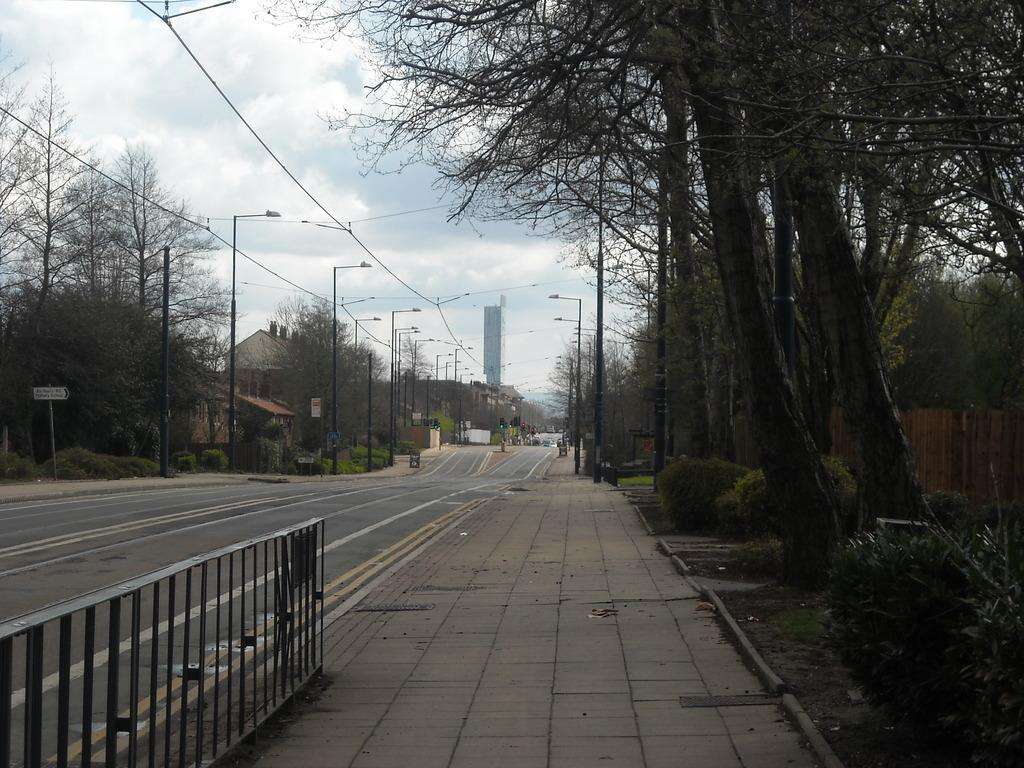What type of natural elements can be seen in the image? There are trees in the image. What type of man-made structures are visible in the image? There are buildings in the image. What type of lighting is present in the image? Street lamps are present in the image. What is visible at the top of the image? The sky is visible at the top of the image. Can you see a shoe hanging from the tree in the image? There is no shoe hanging from the tree in the image. Is there a fingerprint visible on the building in the image? There is no fingerprint visible on the building in the image. 